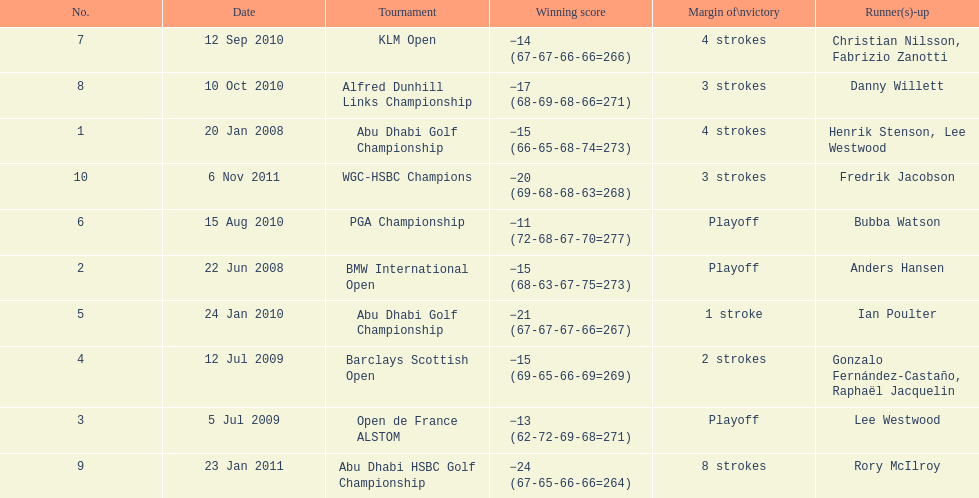How many tournaments has he won by 3 or more strokes? 5. 